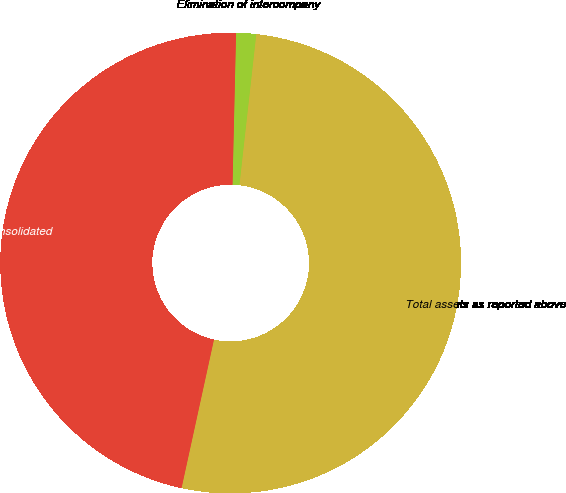<chart> <loc_0><loc_0><loc_500><loc_500><pie_chart><fcel>Total assets as reported above<fcel>Elimination of intercompany<fcel>Total assets per Consolidated<nl><fcel>51.65%<fcel>1.4%<fcel>46.95%<nl></chart> 